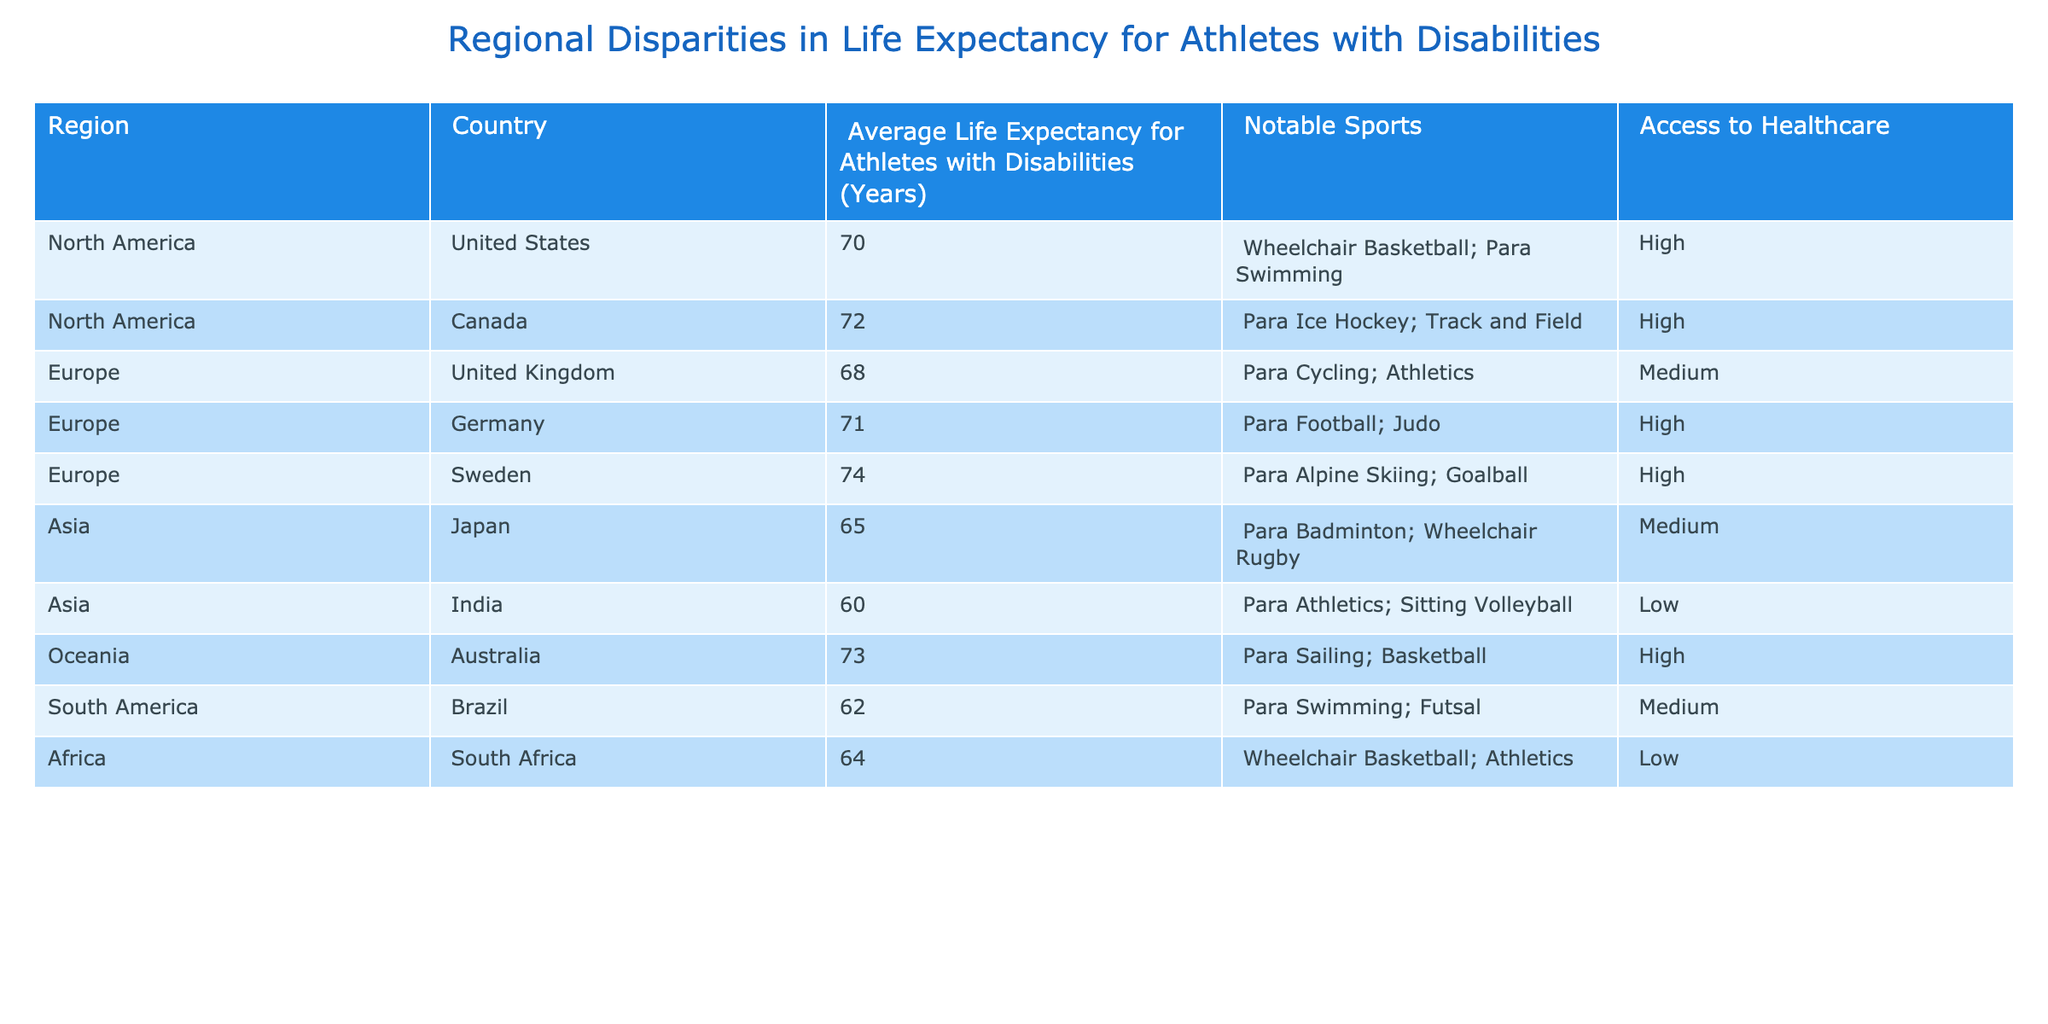What is the average life expectancy for athletes with disabilities in North America? To find the average life expectancy for North America, we need to take the values from the United States (70 years) and Canada (72 years). Now, adding these values gives us 70 + 72 = 142 years. Dividing by the number of countries (2) results in an average life expectancy of 142/2 = 71 years.
Answer: 71 Which region has the highest average life expectancy for athletes with disabilities? By examining the life expectancy values for each region: North America (71), Europe (71), Asia (62.5), Oceania (73), South America (62), and Africa (64), we find that Oceania has the highest life expectancy, which is 73 years.
Answer: Oceania Do athletes with disabilities in Asia have higher life expectancy than those in South America? The average life expectancy for athletes with disabilities in Asia is (65 + 60) / 2 = 62.5 years, while for South America, it is 62 years. Since 62.5 years is greater than 62 years, the statement is true.
Answer: Yes What is the difference in life expectancy between the athlete populations in the United Kingdom and Germany? The life expectancy for athletes in the United Kingdom is 68 years, and in Germany, it is 71 years. To find the difference, we subtract: 71 - 68 = 3 years.
Answer: 3 Which country has the lowest average life expectancy for athletes with disabilities, and what is that value? By reviewing the table, we note that India has the lowest life expectancy at 60 years for athletes with disabilities.
Answer: India, 60 Does access to healthcare have any correlation with life expectancy for athletes with disabilities in the regions listed? Upon examining the table, we note that regions with high healthcare access (North America, Germany, Sweden, Australia) show higher life expectancies, compared to those with low healthcare access (India, South Africa). This suggests a possible positive correlation.
Answer: Yes What is the median life expectancy for athletes with disabilities across all the regions? First, we list the life expectancy values in order: 60, 62, 64, 65, 68, 70, 71, 72, 73, 74. There are 10 values, so the median is the average of the 5th and 6th values: (68 + 70) / 2 = 69 years.
Answer: 69 Is the average life expectancy for athletes with disabilities in Canada higher than that in the United States? In Canada, the life expectancy is 72 years, and in the United States, it is 70 years. Since 72 is greater than 70, this statement is true.
Answer: Yes What percentage of the regions listed have high access to healthcare? There are a total of 10 regions, and 6 of them have high access to healthcare (United States, Canada, Germany, Sweden, Australia). To find the percentage, we calculate (6 / 10) * 100 = 60%.
Answer: 60% 